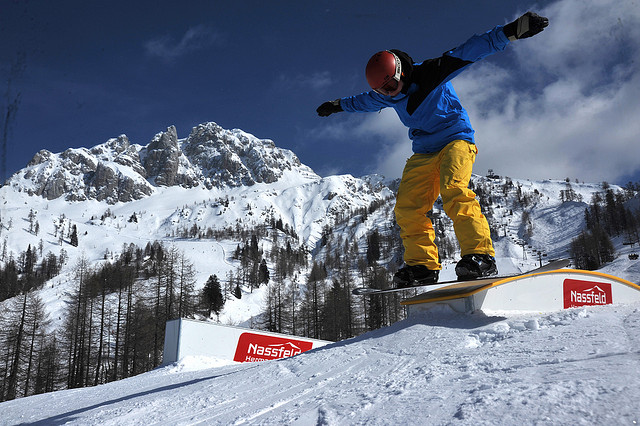What other activities besides snowboarding might take place in this location? This picturesque location is likely a haven for various winter sports and activities. Besides snowboarding, one might see skiing enthusiasts carving down the slopes, families enjoying toboggan rides, and adventurous individuals embarking on snowshoeing expeditions through the wooded areas. The serene environment could also attract photographers capturing the breathtaking scenery, as well as hikers and mountaineers exploring the rugged terrain. Additionally, it might serve as a tranquil retreat for those seeking to reflect and immerse themselves in the beauty of nature. 